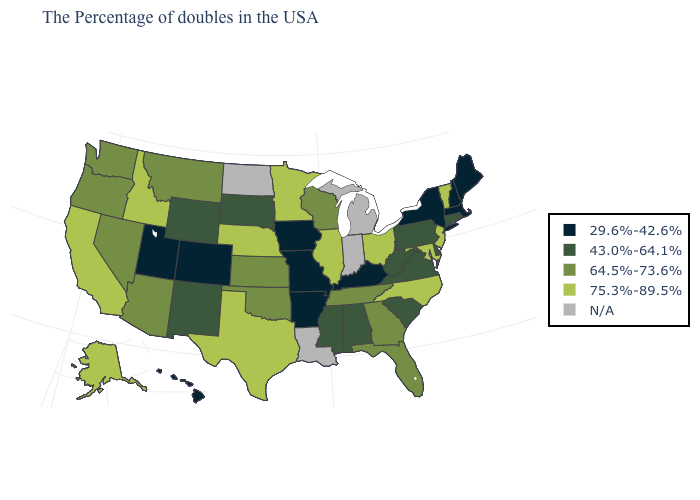What is the highest value in the USA?
Write a very short answer. 75.3%-89.5%. Among the states that border Massachusetts , which have the highest value?
Be succinct. Vermont. Which states have the highest value in the USA?
Be succinct. Vermont, New Jersey, Maryland, North Carolina, Ohio, Illinois, Minnesota, Nebraska, Texas, Idaho, California, Alaska. Which states have the lowest value in the USA?
Concise answer only. Maine, Massachusetts, New Hampshire, New York, Kentucky, Missouri, Arkansas, Iowa, Colorado, Utah, Hawaii. Does Montana have the lowest value in the USA?
Keep it brief. No. What is the lowest value in the USA?
Short answer required. 29.6%-42.6%. Which states have the lowest value in the USA?
Keep it brief. Maine, Massachusetts, New Hampshire, New York, Kentucky, Missouri, Arkansas, Iowa, Colorado, Utah, Hawaii. What is the value of Oregon?
Answer briefly. 64.5%-73.6%. Which states have the lowest value in the Northeast?
Keep it brief. Maine, Massachusetts, New Hampshire, New York. What is the lowest value in the South?
Concise answer only. 29.6%-42.6%. What is the highest value in the Northeast ?
Quick response, please. 75.3%-89.5%. What is the value of Arizona?
Give a very brief answer. 64.5%-73.6%. Name the states that have a value in the range 75.3%-89.5%?
Give a very brief answer. Vermont, New Jersey, Maryland, North Carolina, Ohio, Illinois, Minnesota, Nebraska, Texas, Idaho, California, Alaska. What is the value of Alaska?
Keep it brief. 75.3%-89.5%. 